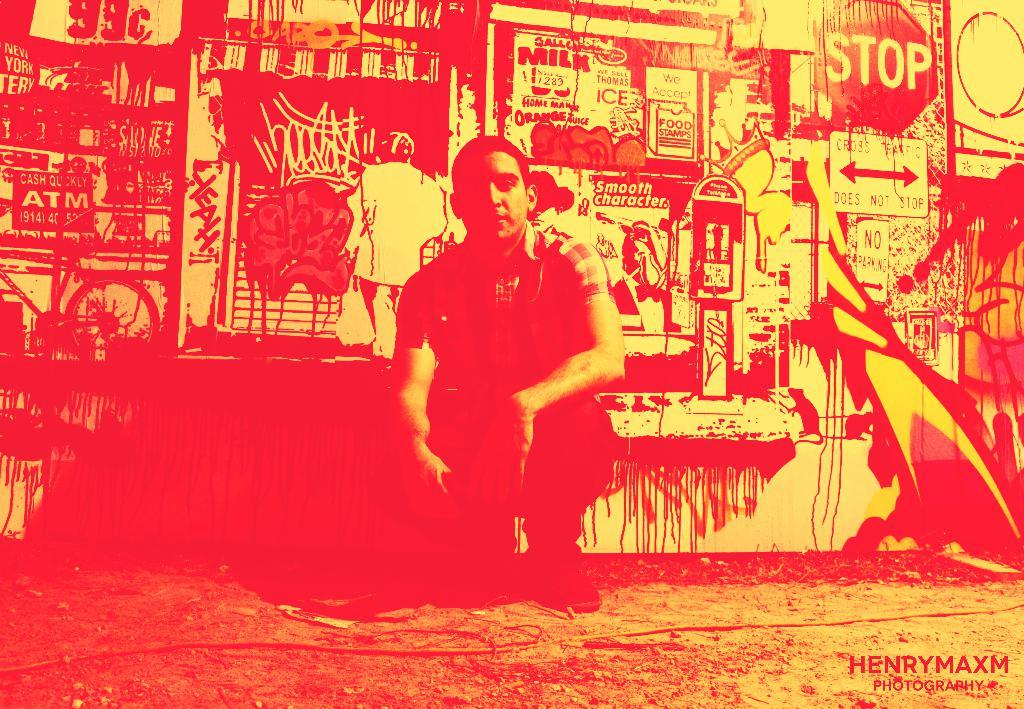Provide a one-sentence caption for the provided image. HenryMaxm photography includes a guy posing for a picture. 